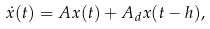Convert formula to latex. <formula><loc_0><loc_0><loc_500><loc_500>\dot { x } ( t ) = A x ( t ) + A _ { d } x ( t - h ) ,</formula> 